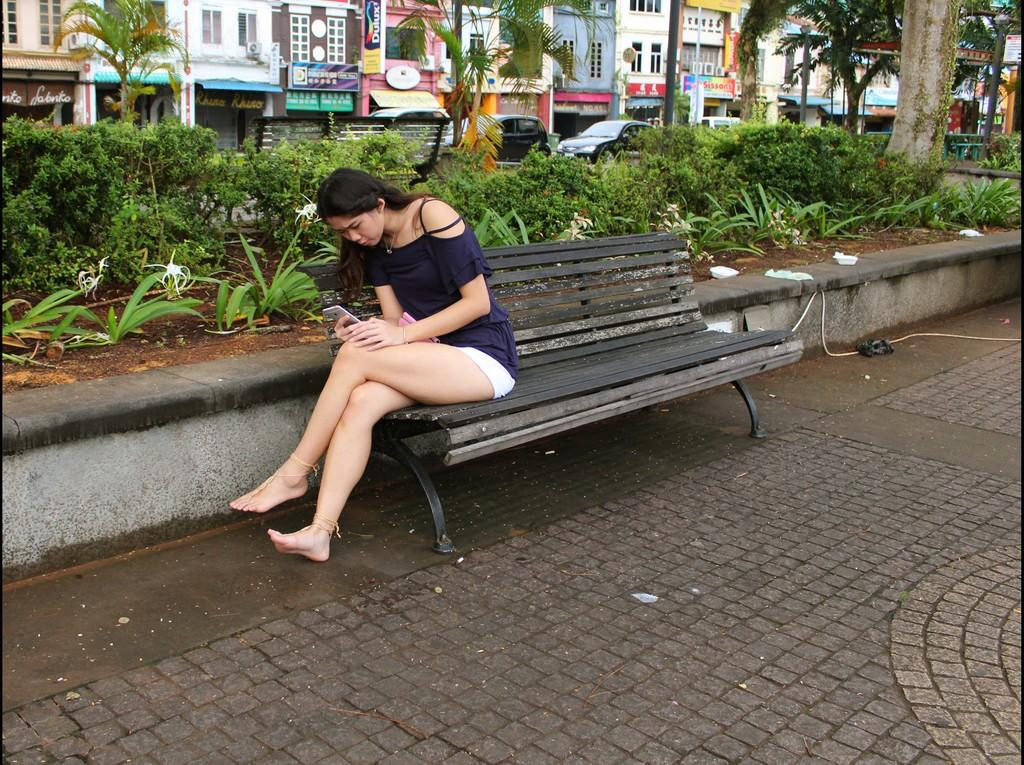What is the main feature of the image? There is an open space in the image. What is the woman in the image doing? The woman is sitting on a chair and operating a mobile phone. What can be seen in the background of the image? There are trees, buildings, and cars in the background of the image. What is the woman's income based on her appearance in the image? There is no information about the woman's income in the image, so it cannot be determined. 